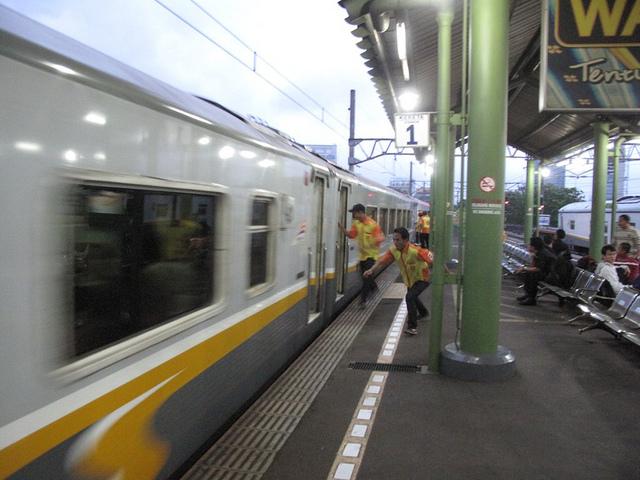What colors are the people on the platforms' shirts?
Write a very short answer. Yellow and orange. Are the people running to get in?
Keep it brief. Yes. Is the train moving?
Answer briefly. Yes. Why are the people running?
Short answer required. To catch train. 